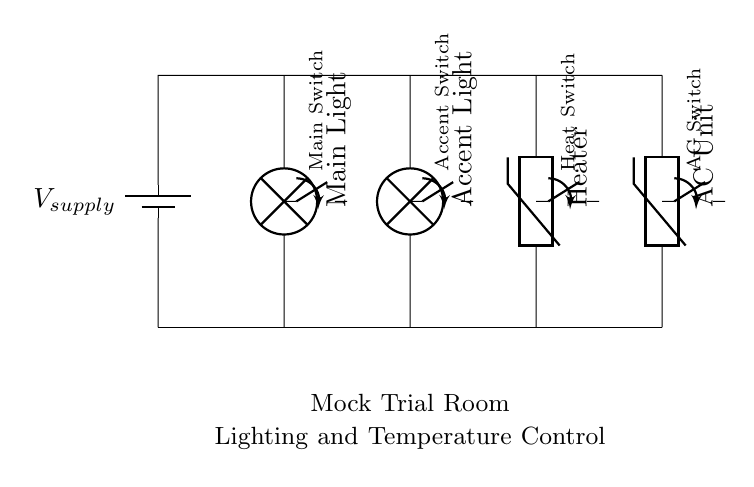What components are present in the circuit? The circuit includes four main components: Main Light, Accent Light, Heater, and AC Unit, which are all arranged in parallel.
Answer: Main Light, Accent Light, Heater, AC Unit What type of circuit is this? This is a parallel circuit, as all components are connected across the same two points, allowing them to operate independently of each other.
Answer: Parallel circuit How many switches are included in the circuit? There are four switches in the circuit that control each component individually: Main Switch, Accent Switch, Heat Switch, and AC Switch.
Answer: Four If the voltage supply is 12 volts, what voltage is across each lamp and thermistor? Each lamp and thermistor receives the full supply voltage, which is 12 volts, as voltage is the same across all components in a parallel circuit.
Answer: 12 volts What happens if one of the lamps is switched off? If the Main Light or Accent Light is switched off, the other components (Heater, AC Unit) will continue to function since they are in parallel, allowing independent operation.
Answer: Others continue functioning Which component type controls the temperature? The circuit includes two thermistors, a Heater and an AC Unit, which control the temperature of the room based on their operation.
Answer: Thermistors What is the role of the main switch? The main switch controls the Main Light, allowing it to be turned on or off independently from the other components in the circuit.
Answer: Control Main Light 